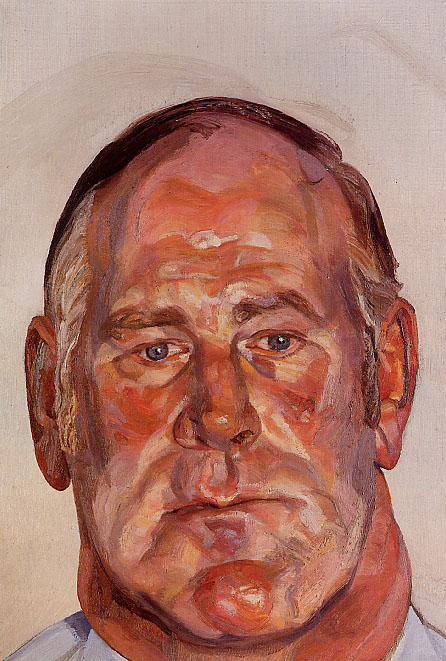How does the choice of colors impact the overall emotion of the painting? The choice of warm, vibrant colors such as oranges, reds, and pinks significantly heightens the emotional impact of the painting. These hues are not only eye-catching but also evoke feelings of warmth, vitality, and intensity. The dynamic combination and application of these colors with thick brushstrokes add to the sense of movement and emotional depth in the portrait. The contrast with the pale beige background further accentuates the man's facial features and expression, focusing the viewer’s attention on the emotions conveyed through his closed eyes and introspective demeanor. 